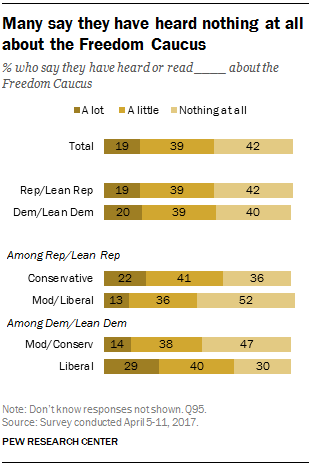Identify some key points in this picture. The ratio (A: B) of "A little" bar occurrences with values 39 and "Nothing at all" bar occurrences with values 42 is 0.126388889... According to a recent survey, only 0.29% of self-identified liberals claim to have heard or read a lot about the Freedom Caucus. 